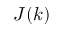<formula> <loc_0><loc_0><loc_500><loc_500>J ( k )</formula> 